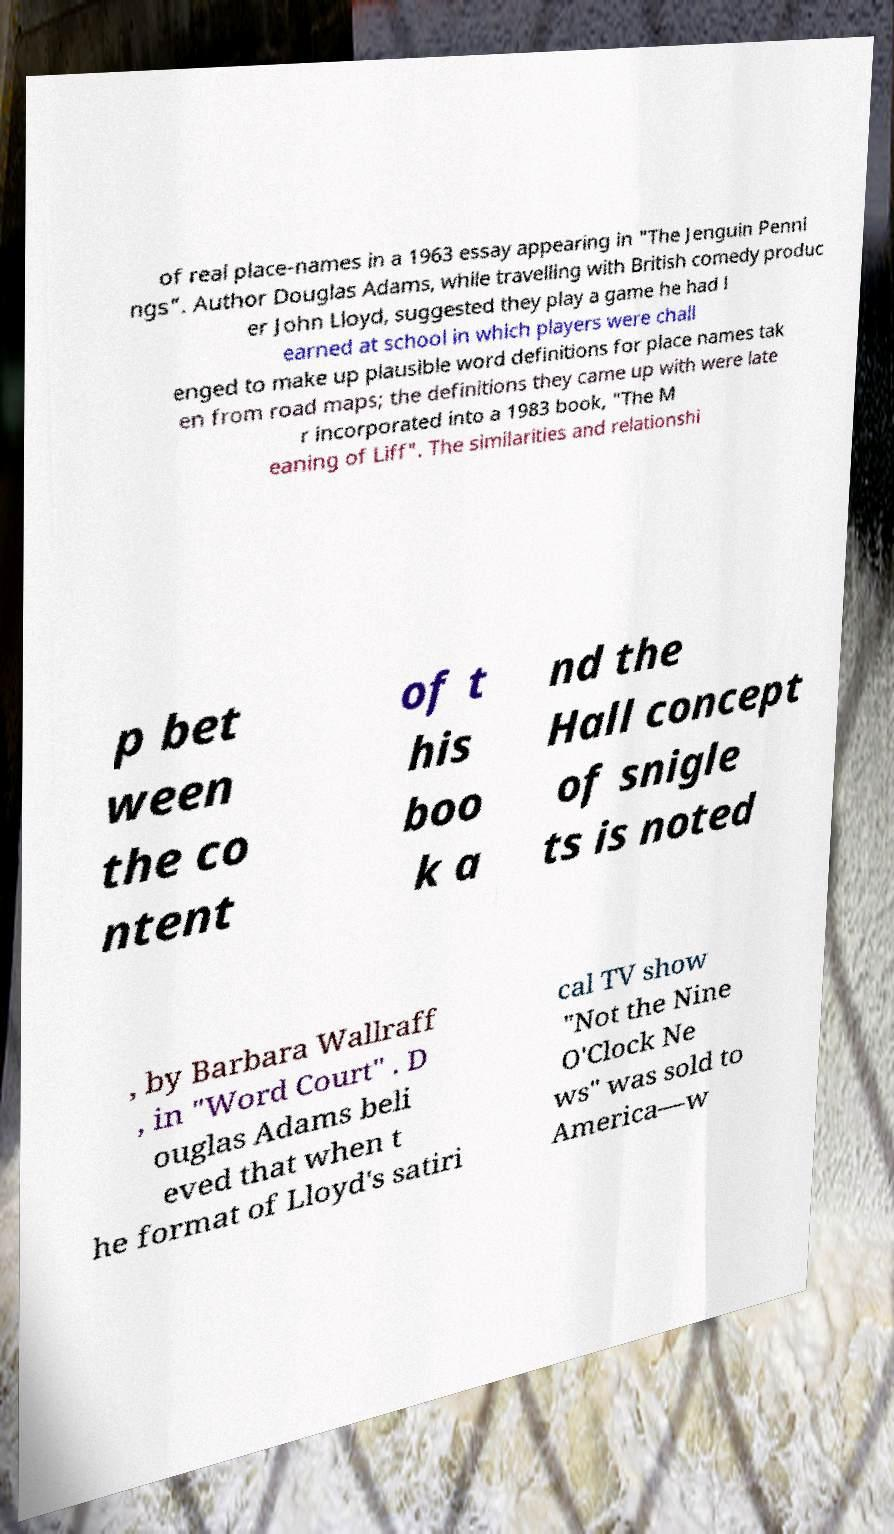Please read and relay the text visible in this image. What does it say? of real place-names in a 1963 essay appearing in "The Jenguin Penni ngs". Author Douglas Adams, while travelling with British comedy produc er John Lloyd, suggested they play a game he had l earned at school in which players were chall enged to make up plausible word definitions for place names tak en from road maps; the definitions they came up with were late r incorporated into a 1983 book, "The M eaning of Liff". The similarities and relationshi p bet ween the co ntent of t his boo k a nd the Hall concept of snigle ts is noted , by Barbara Wallraff , in "Word Court" . D ouglas Adams beli eved that when t he format of Lloyd's satiri cal TV show "Not the Nine O'Clock Ne ws" was sold to America—w 